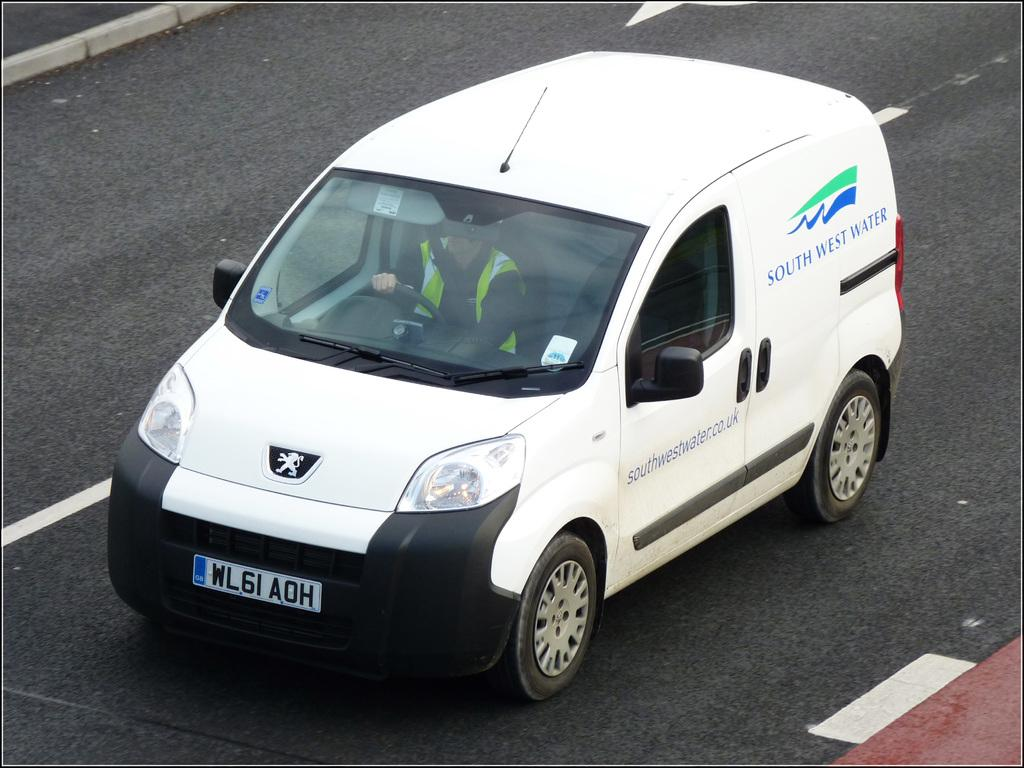Provide a one-sentence caption for the provided image. A white South West Water van is being driven by a driver in a yellow vest. 